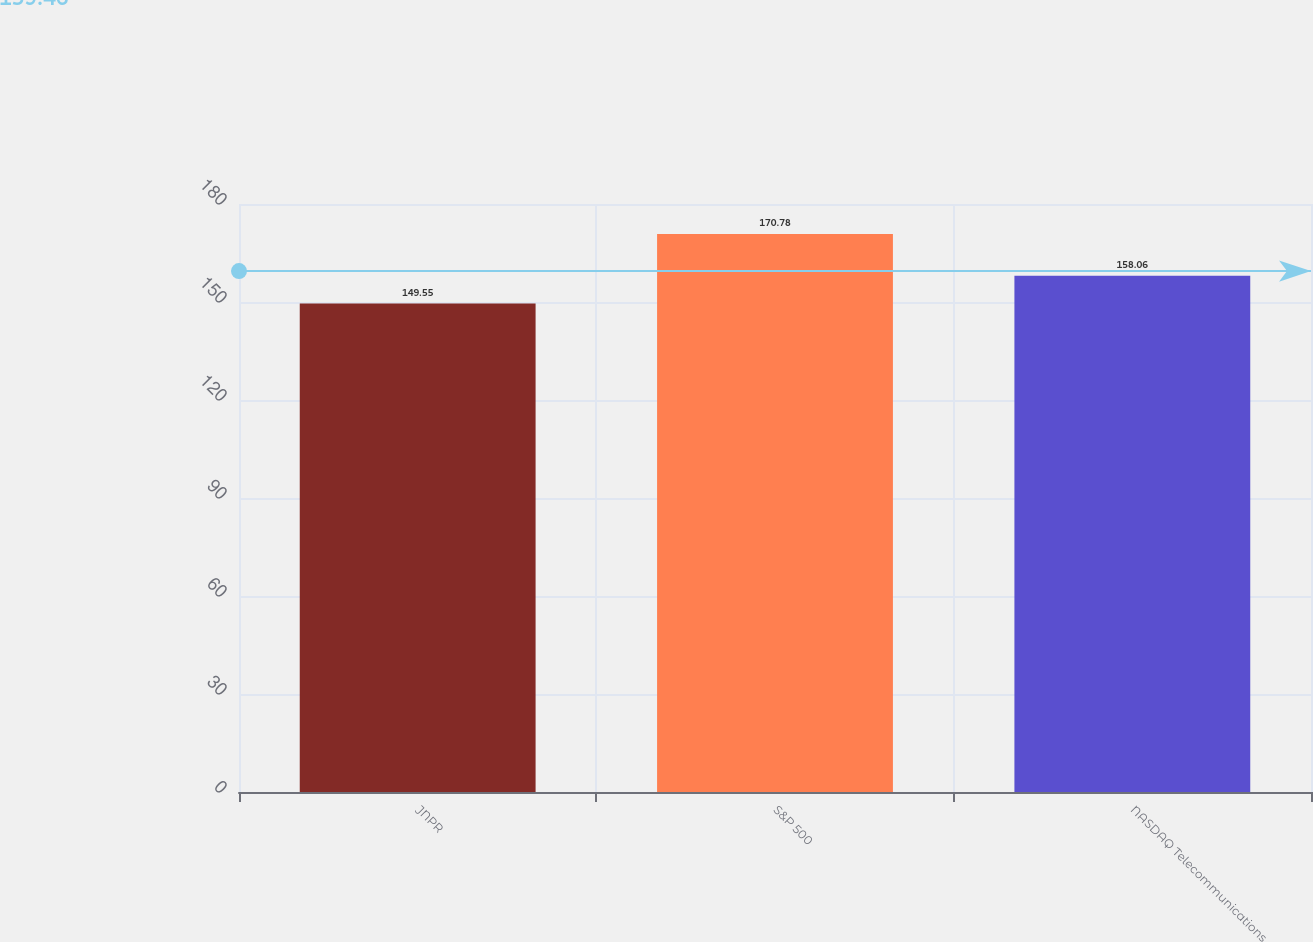<chart> <loc_0><loc_0><loc_500><loc_500><bar_chart><fcel>JNPR<fcel>S&P 500<fcel>NASDAQ Telecommunications<nl><fcel>149.55<fcel>170.78<fcel>158.06<nl></chart> 